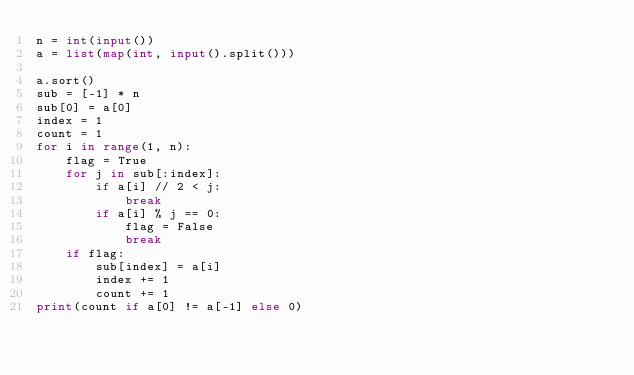Convert code to text. <code><loc_0><loc_0><loc_500><loc_500><_Python_>n = int(input())
a = list(map(int, input().split()))

a.sort()
sub = [-1] * n
sub[0] = a[0]
index = 1
count = 1
for i in range(1, n):
    flag = True
    for j in sub[:index]:
        if a[i] // 2 < j:
            break
        if a[i] % j == 0:
            flag = False
            break
    if flag:
        sub[index] = a[i]
        index += 1
        count += 1
print(count if a[0] != a[-1] else 0)
</code> 